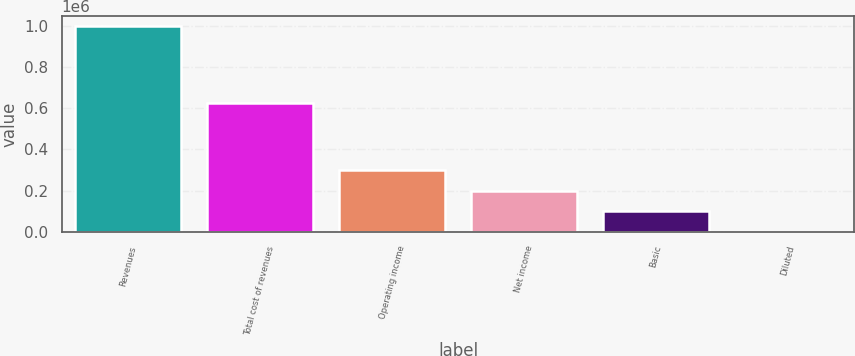<chart> <loc_0><loc_0><loc_500><loc_500><bar_chart><fcel>Revenues<fcel>Total cost of revenues<fcel>Operating income<fcel>Net income<fcel>Basic<fcel>Diluted<nl><fcel>996660<fcel>626985<fcel>298998<fcel>199333<fcel>99666.6<fcel>0.71<nl></chart> 